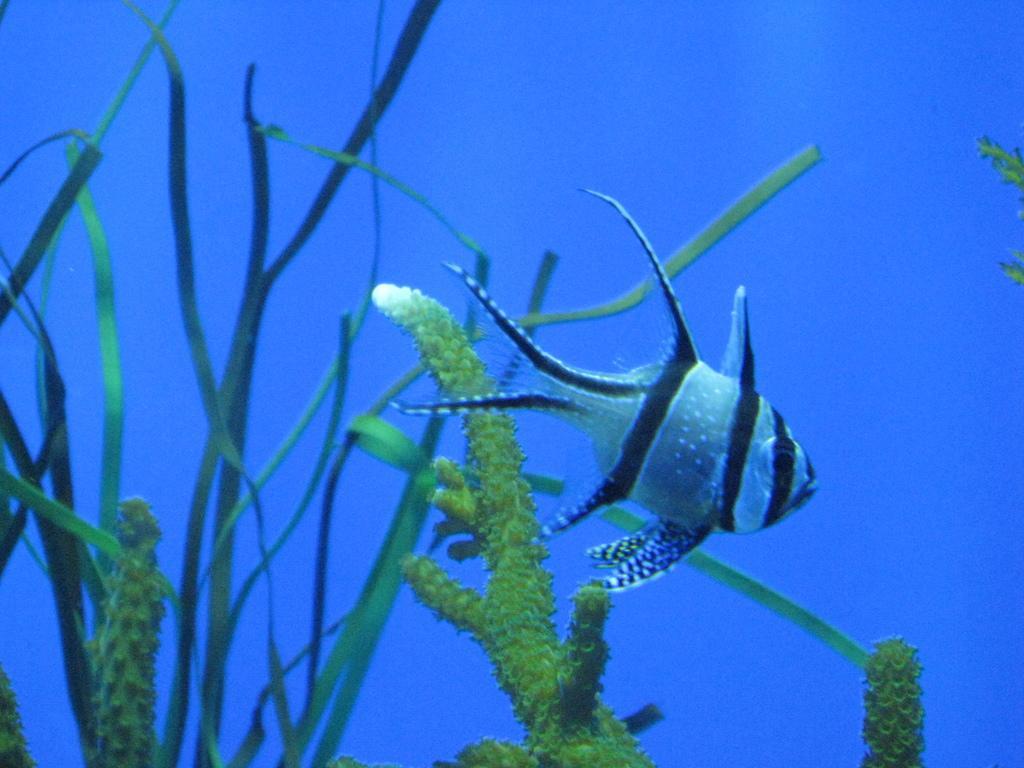Can you describe this image briefly? In this picture we can see a fish and plants in the water. Behind the fish there is a blue background. 